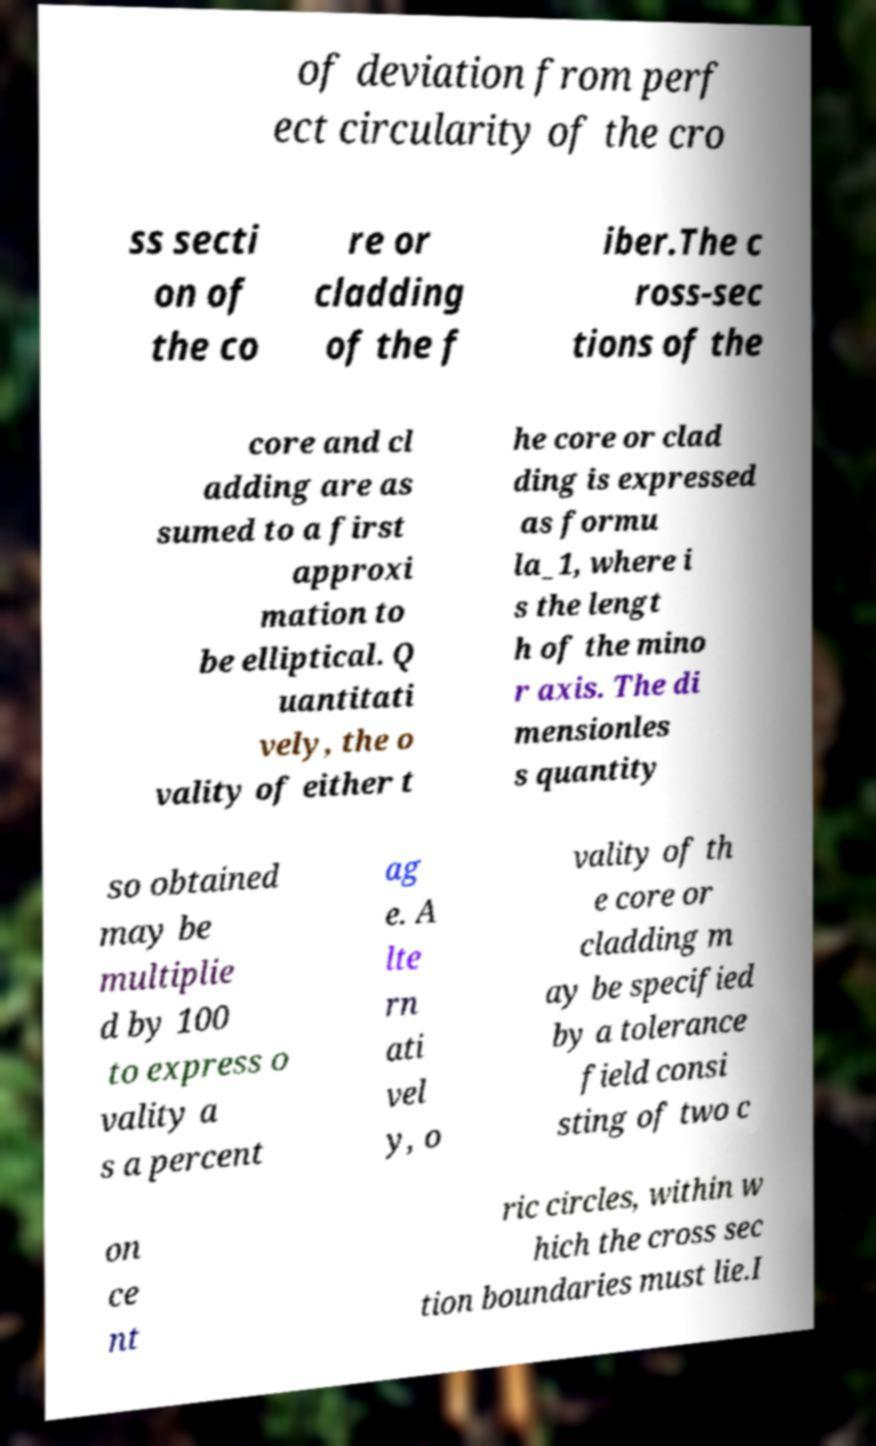For documentation purposes, I need the text within this image transcribed. Could you provide that? of deviation from perf ect circularity of the cro ss secti on of the co re or cladding of the f iber.The c ross-sec tions of the core and cl adding are as sumed to a first approxi mation to be elliptical. Q uantitati vely, the o vality of either t he core or clad ding is expressed as formu la_1, where i s the lengt h of the mino r axis. The di mensionles s quantity so obtained may be multiplie d by 100 to express o vality a s a percent ag e. A lte rn ati vel y, o vality of th e core or cladding m ay be specified by a tolerance field consi sting of two c on ce nt ric circles, within w hich the cross sec tion boundaries must lie.I 